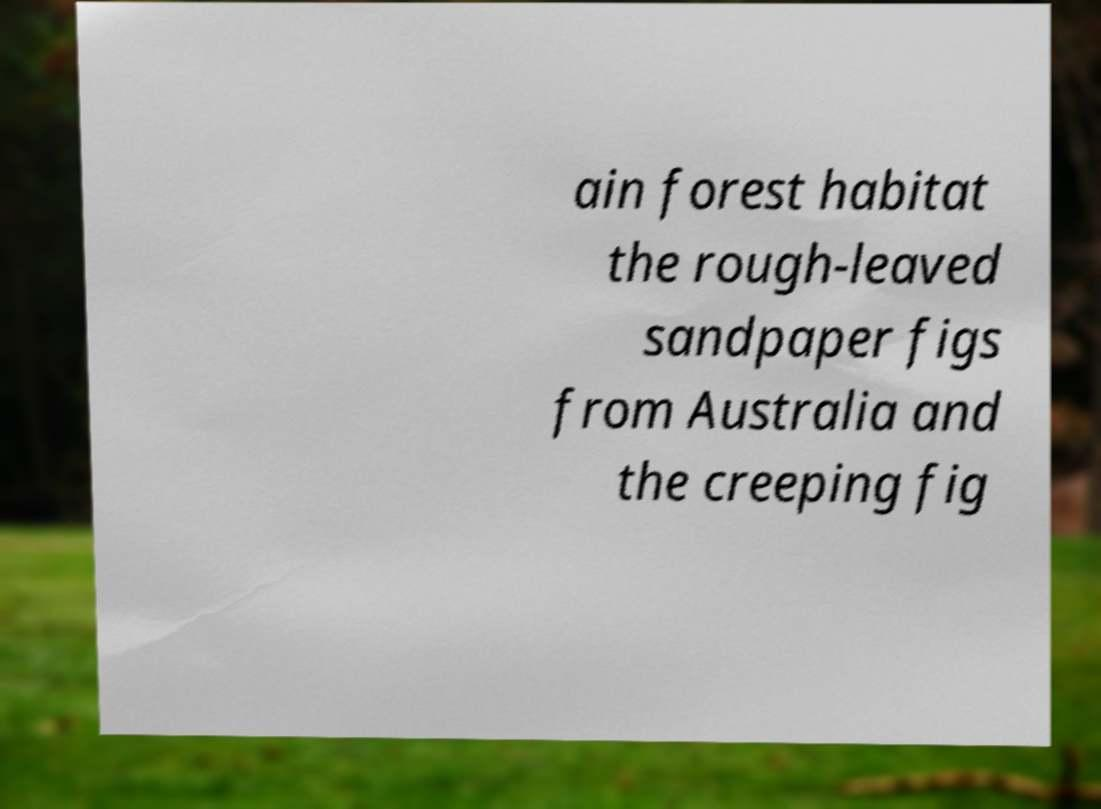Please read and relay the text visible in this image. What does it say? ain forest habitat the rough-leaved sandpaper figs from Australia and the creeping fig 